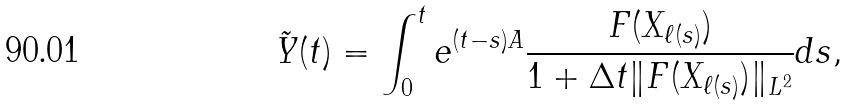<formula> <loc_0><loc_0><loc_500><loc_500>\tilde { Y } ( t ) = \int _ { 0 } ^ { t } e ^ { ( t - s ) A } \frac { F ( X _ { \ell ( s ) } ) } { 1 + \Delta t \| F ( X _ { \ell ( s ) } ) \| _ { L ^ { 2 } } } d s ,</formula> 